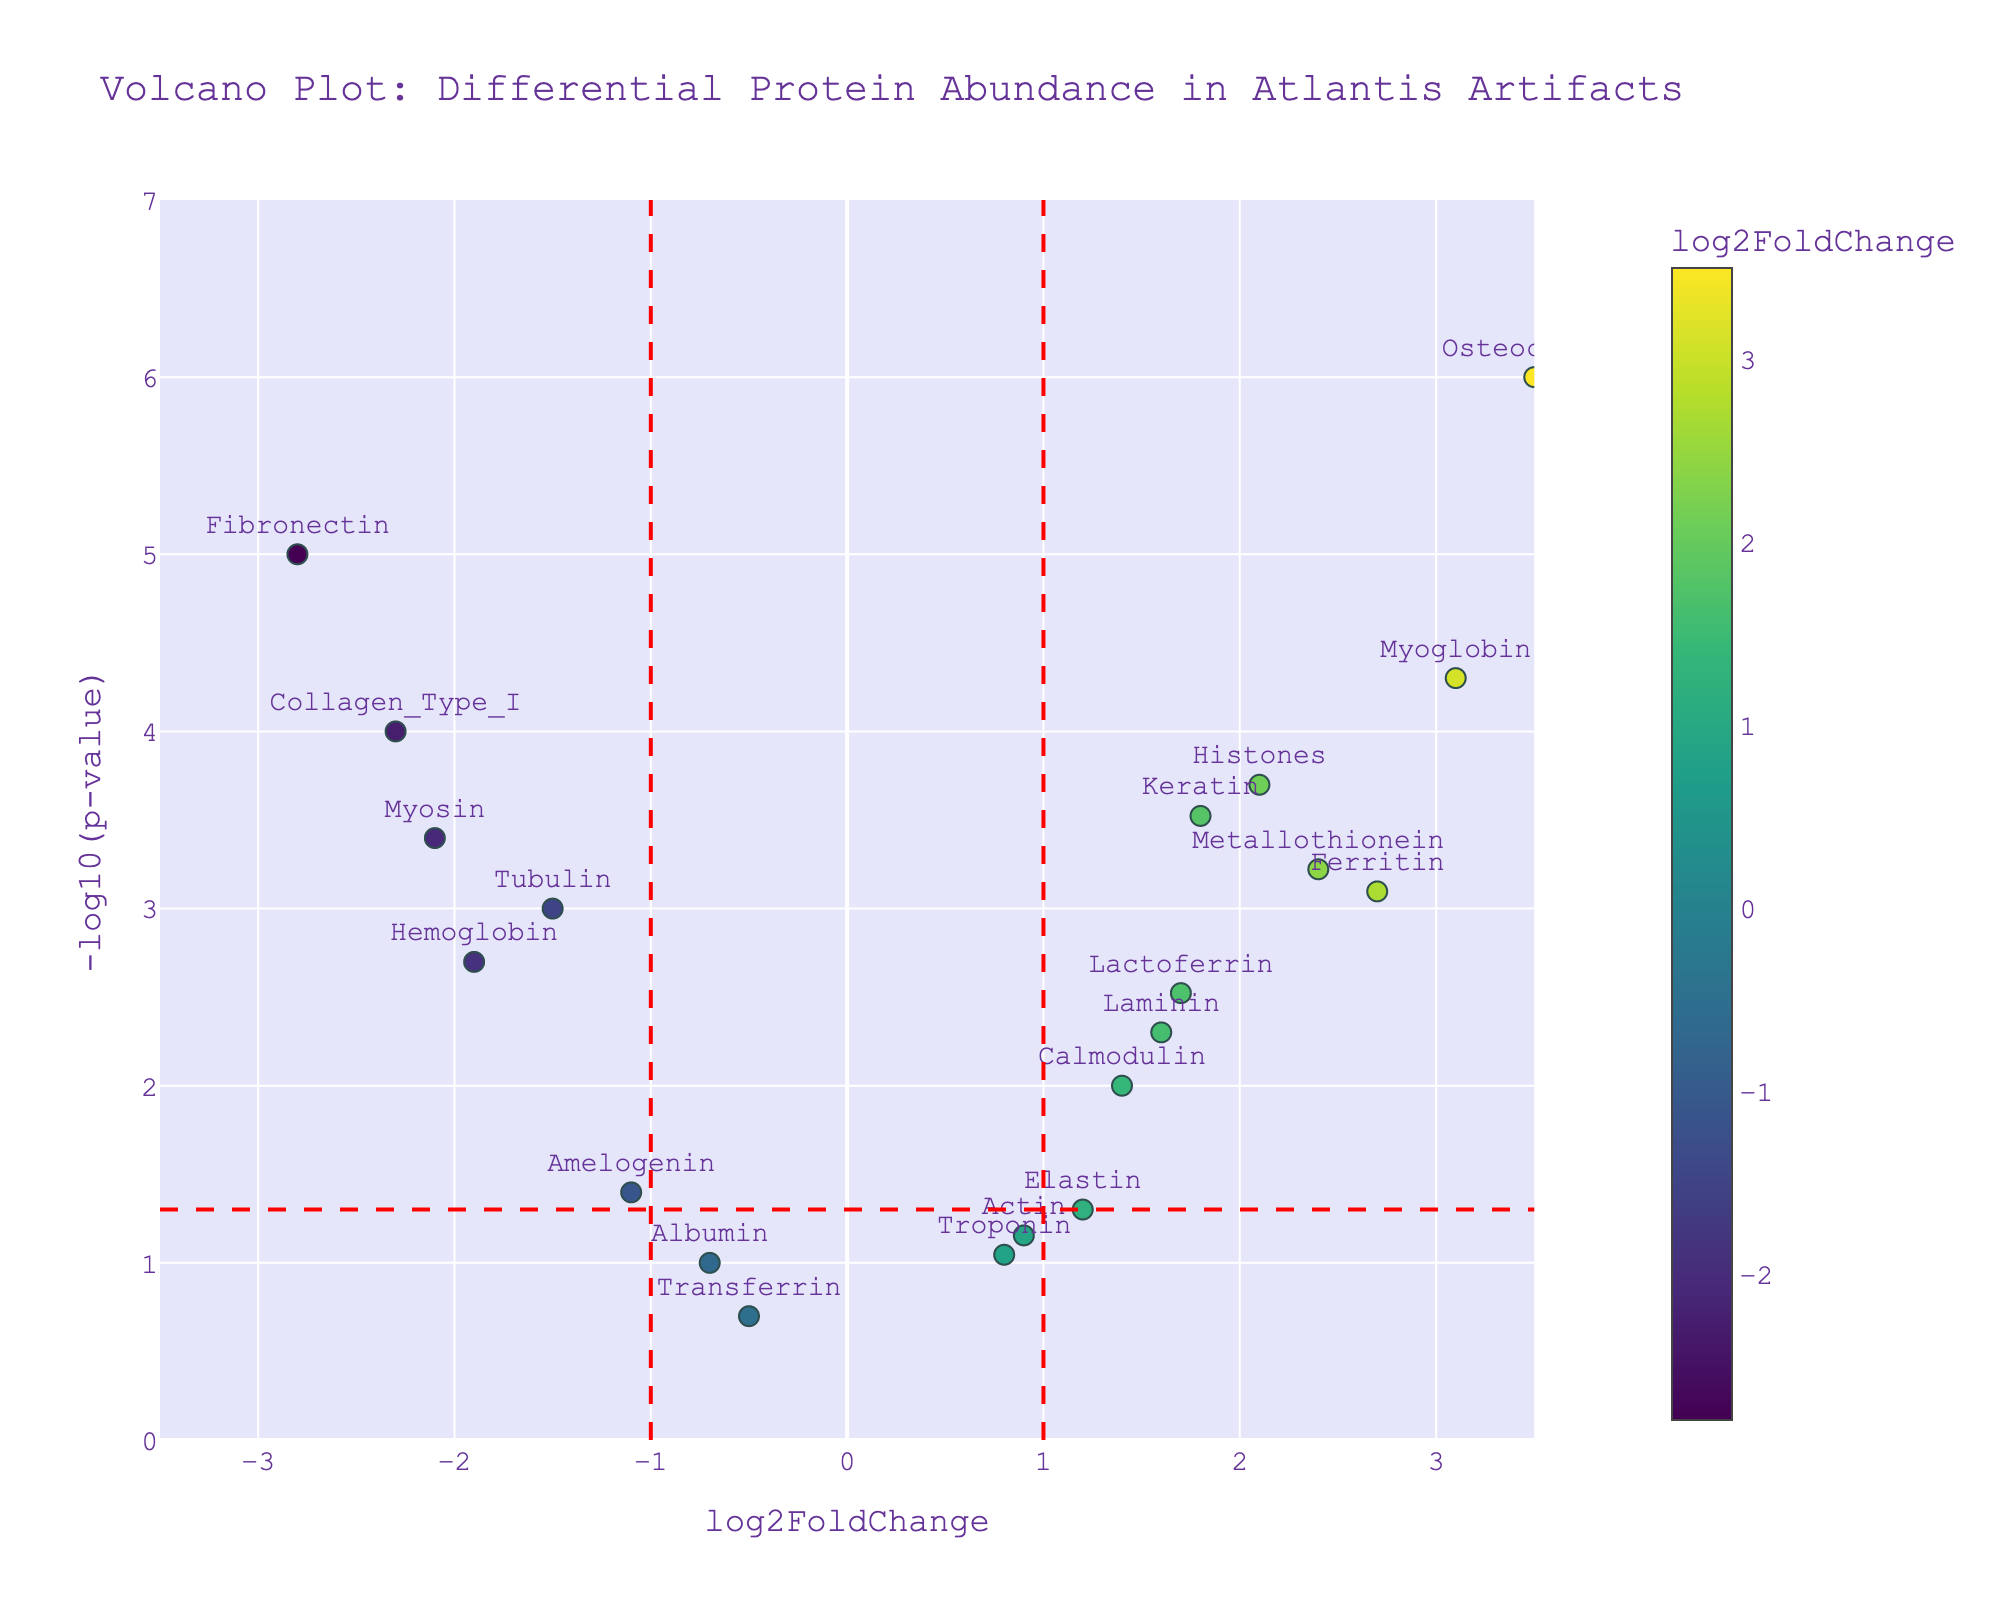What is the title of the figure? The title of the figure is usually positioned at the top and represents the main message of the figure. In this case, it reads "Volcano Plot: Differential Protein Abundance in Atlantis Artifacts".
Answer: Volcano Plot: Differential Protein Abundance in Atlantis Artifacts What are the x-axis and y-axis labels? The x-axis represents the log2FoldChange values, as stated by its label, and the y-axis represents the -log10(p-value), as indicated by its label.
Answer: x-axis: log2FoldChange, y-axis: -log10(p-value) How many proteins have p-values less than 0.05? Proteins with p-values less than 0.05 will have -log10(p-value) greater than or equal to 1.3 (since -log10(0.05) ≈ 1.3). By counting the data points above the horizontal red dashed line, we can determine there are 13 such proteins.
Answer: 13 proteins Which protein has the highest -log10(p-value)? The highest -log10(p-value) corresponds to the largest y-value on the plot. According to the data and visual inspection of the figure, Osteocalcin has the highest value.
Answer: Osteocalcin How many proteins have log2FoldChange values greater than 1? The proteins can be counted which are to the right of the vertical red dashed line at 1. By counting these points on the plot, we find there are 8 such proteins.
Answer: 8 proteins Which proteins have significantly reduced abundance (log2FoldChange less than -1) and statistically significant p-values (p-value less than 0.05)? These proteins would be left of the vertical red dashed line at -1 and above the horizontal red dashed line. The proteins that satisfy these criteria are: Collagen_Type_I, Fibronectin, Myosin, and Tubulin.
Answer: Collagen_Type_I, Fibronectin, Myosin, Tubulin Compare the abundance change between Ferritin and Amelogenin. Which has higher absolute log2FoldChange and are they statistically significant? Ferritin's log2FoldChange is 2.7 while Amelogenin's is -1.1. Ferritin has a higher absolute log2FoldChange (2.7 > 1.1 in magnitude). Both proteins have p-values less than 0.05, making them statistically significant.
Answer: Ferritin, yes Identify the protein with the lowest log2FoldChange but statistically significant p-value (p-value less than 0.05). The lowest log2FoldChange can be found by looking at the leftmost data point above the horizontal red dashed line. Fibronectin has the lowest log2FoldChange of -2.8 while having a statistically significant p-value.
Answer: Fibronectin How does the abundance of Histones compare with that of Actin in terms of log2FoldChange, and are they both statistically significant? Comparing the positions, Histones have a log2FoldChange of 2.1 and Actin has a log2FoldChange of 0.9. Only Histones are statistically significant (p-value < 0.05), indicated by being above the horizontal red dashed line for significance.
Answer: Histones, no for Actin Which protein shows minimal change (close to log2FoldChange of 0) and has an insignificant p-value (above the horizontal red dashed line indicating p-value >= 0.05)? The protein closest to the center (log2FoldChange ≈ 0) and above the red horizontal line (indicating insignificance) is Albumin.
Answer: Albumin 